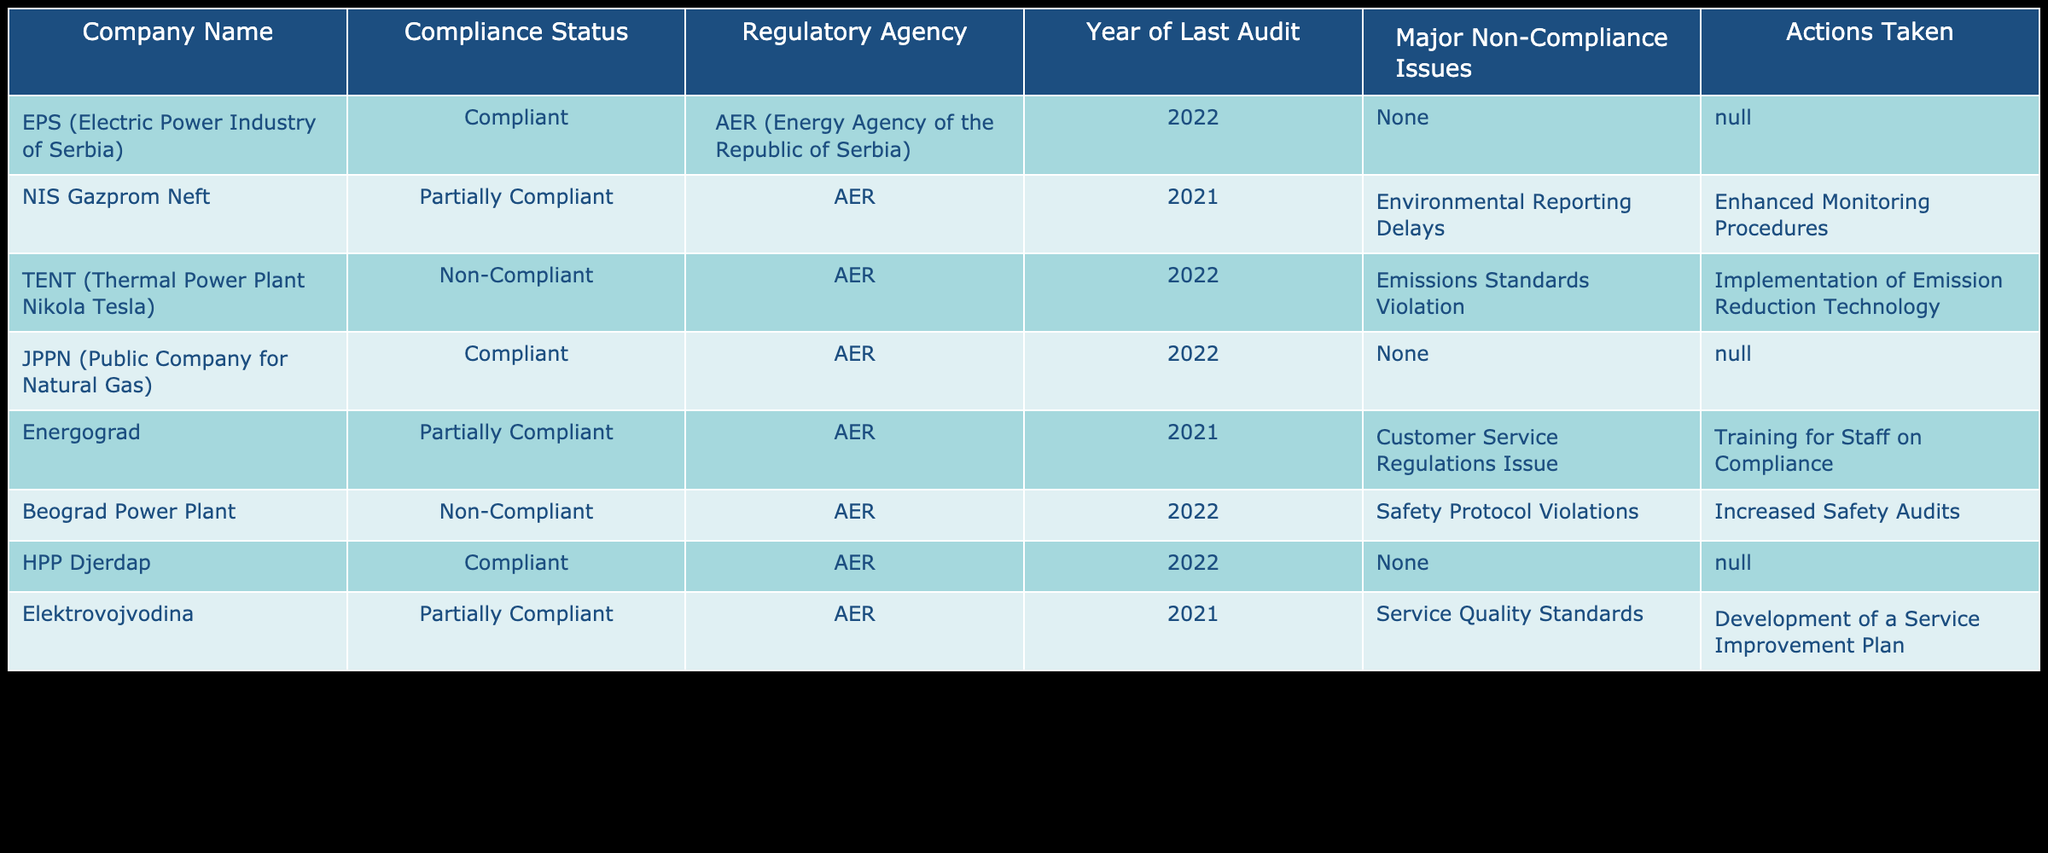What is the compliance status of EPS (Electric Power Industry of Serbia)? According to the table, EPS is marked as "Compliant" under the "Compliance Status" column.
Answer: Compliant Which company has the latest audit year recorded? The table shows that EPS, JPPN, and HPP Djerdap all have the year "2022" under the "Year of Last Audit" column. This means they have the latest audit year recorded.
Answer: EPS, JPPN, HPP Djerdap How many companies are non-compliant? The table lists TENT and Beograd Power Plant as non-compliant under the "Compliance Status" column, resulting in a total of 2 non-compliant companies.
Answer: 2 What actions were taken for companies that are partially compliant? The actions taken for NIS Gazprom Neft include "Enhanced Monitoring Procedures", and for Energograd, it mentions "Training for Staff on Compliance" while Elektrovojvodina's action is "Development of a Service Improvement Plan."
Answer: Enhanced Monitoring Procedures, Training for Staff on Compliance, Development of a Service Improvement Plan Is it true that all compliant companies have no major non-compliance issues? Yes, the table shows that all compliant companies (EPS, JPPN, HPP Djerdap) have "None" listed in the "Major Non-Compliance Issues" column.
Answer: Yes Which regulatory agency oversees the compliance status of these companies? The "Regulatory Agency" column indicates that all listed companies are regulated by the AER (Energy Agency of the Republic of Serbia).
Answer: AER What was the major non-compliance issue for Beograd Power Plant? The table specifies that Beograd Power Plant had a "Safety Protocol Violations" issue as its major non-compliance issue.
Answer: Safety Protocol Violations How many companies had their last audit in 2021? By reviewing the "Year of Last Audit" column, it can be observed that there are three companies (NIS Gazprom Neft, Energograd, and Elektrovojvodina) whose last audit was conducted in 2021.
Answer: 3 What is the average compliance status of the companies based on the classification provided? The table provides compliance statuses: Compliant (3), Partially Compliant (3), and Non-Compliant (2). To calculate the average: Compliant (1) * 3 + Partially Compliant (0.5) * 3 + Non-Compliant (0) * 2 = 3 + 1.5 + 0 = 4.5; Dividing by the number of companies (8): 4.5/8 = 0.5625, or approximately 56.25%.
Answer: 56.25% 